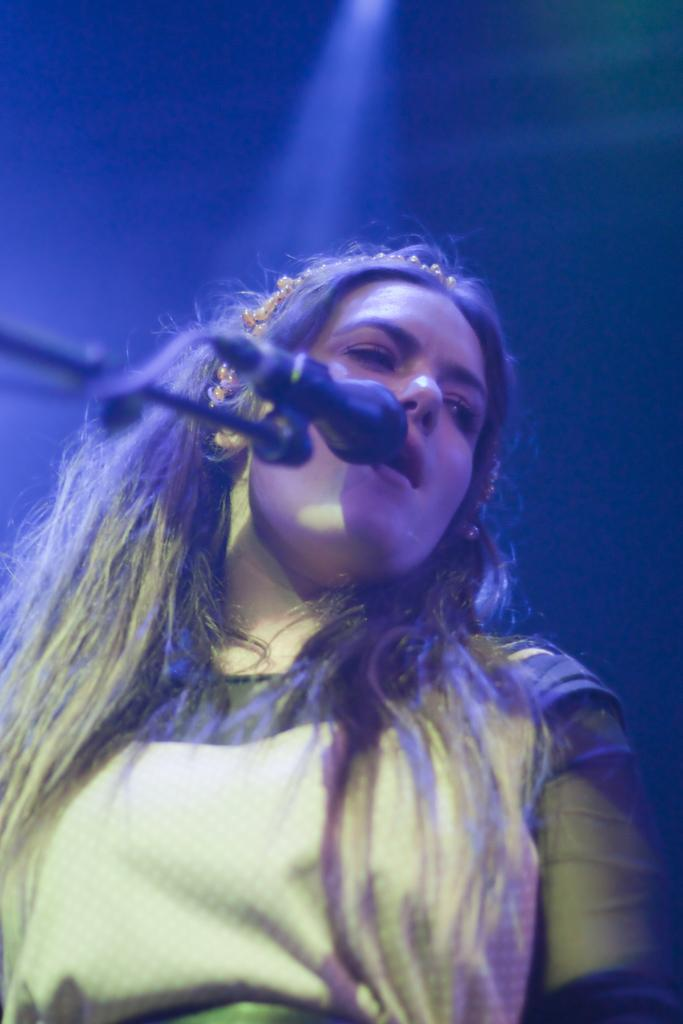Who is the main subject in the image? There is a lady in the image. What is the lady wearing? The lady is wearing a yellow dress. What is the lady doing in the image? The lady is singing. What object is in front of the lady? There is a microphone in front of the lady. How would you describe the background of the image? The background of the image is dark. What letter is the lady holding in her hand while singing in the image? There is no letter present in the image; the lady is holding a microphone while singing. 